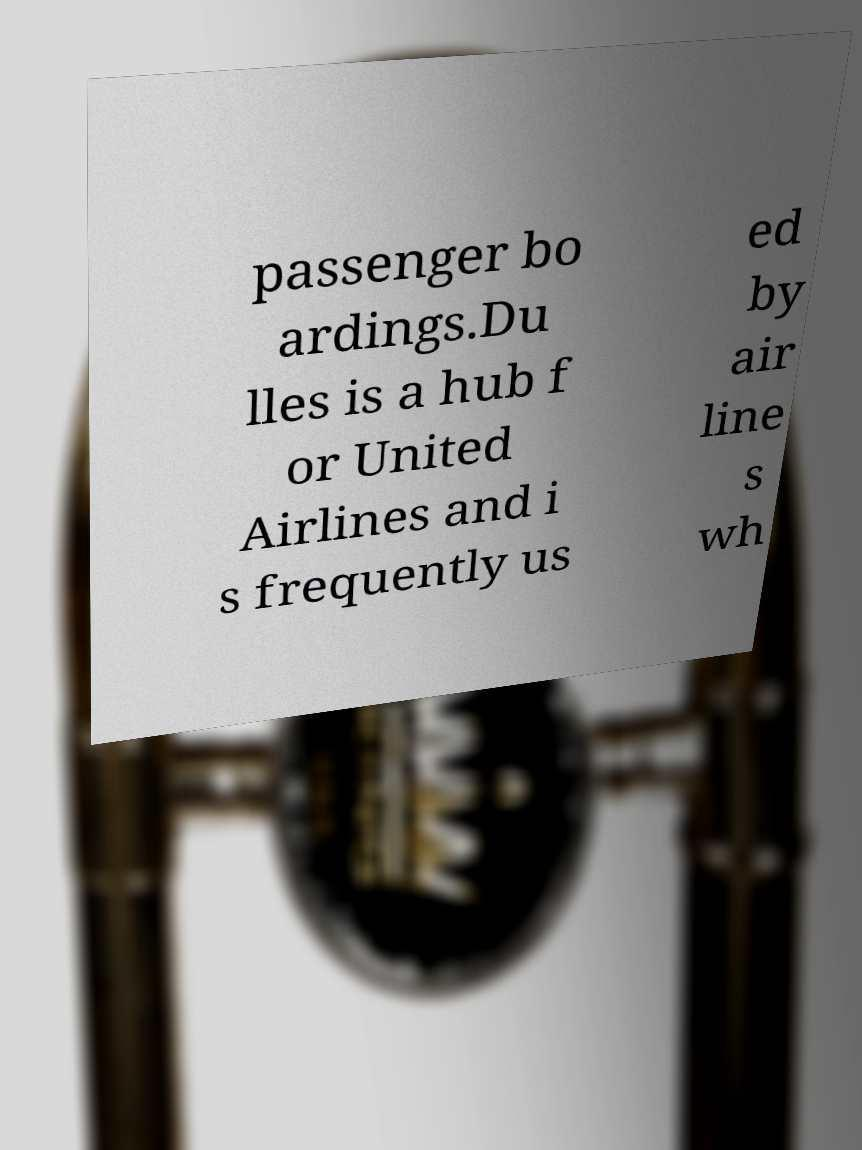For documentation purposes, I need the text within this image transcribed. Could you provide that? passenger bo ardings.Du lles is a hub f or United Airlines and i s frequently us ed by air line s wh 